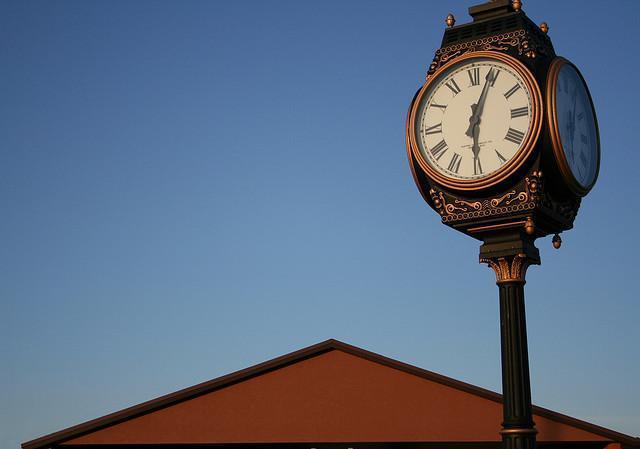How many clocks are there?
Give a very brief answer. 2. 